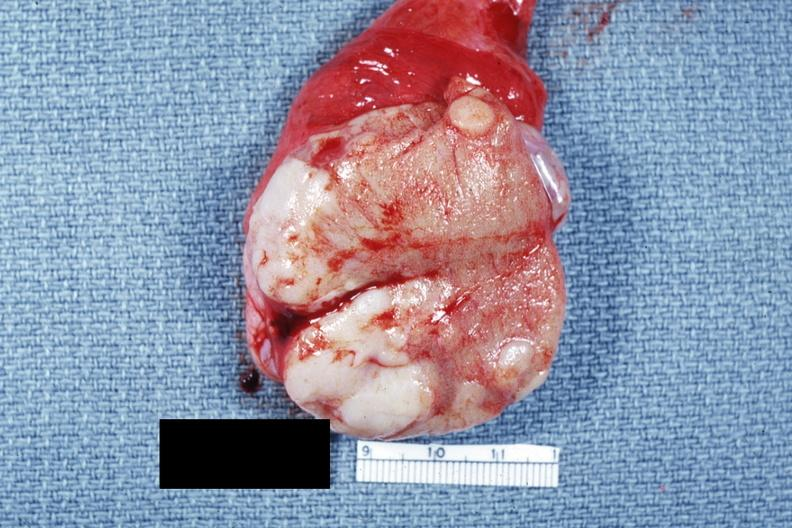s close-up tumor well shown primary not stated said to be adenocarcinoma?
Answer the question using a single word or phrase. Yes 